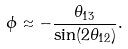<formula> <loc_0><loc_0><loc_500><loc_500>\phi \approx - \frac { \theta _ { 1 3 } } { \sin ( 2 \theta _ { 1 2 } ) } .</formula> 